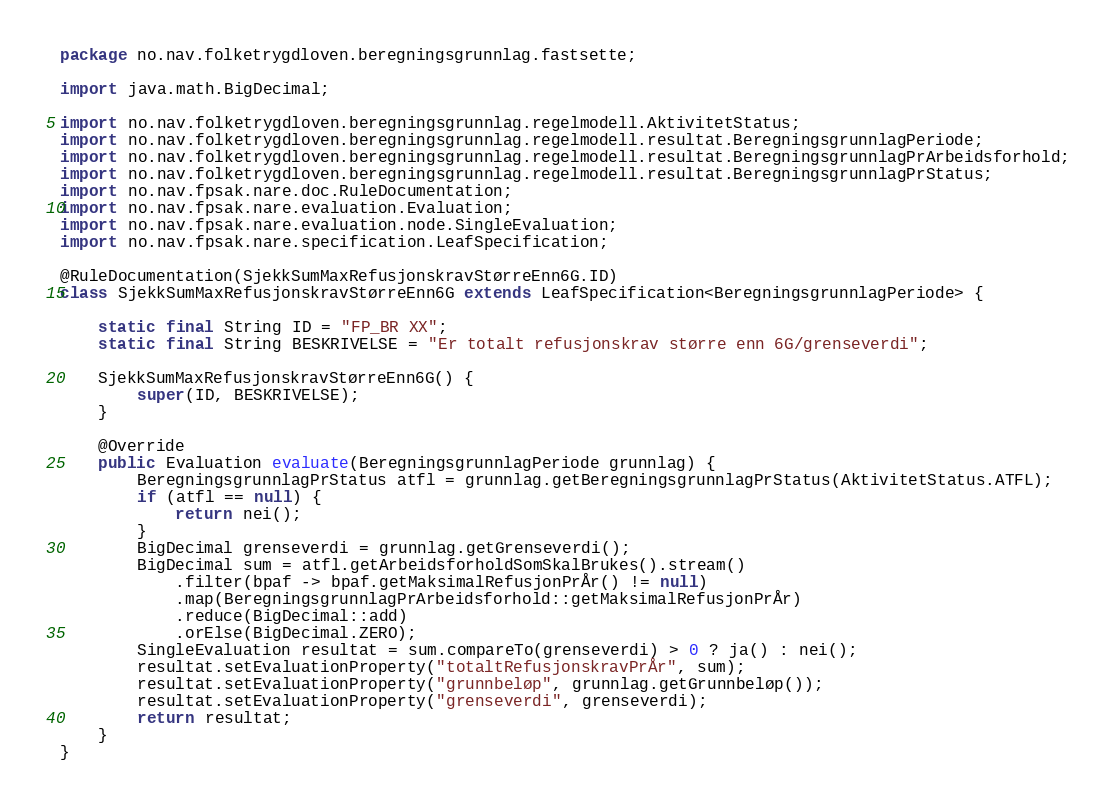Convert code to text. <code><loc_0><loc_0><loc_500><loc_500><_Java_>package no.nav.folketrygdloven.beregningsgrunnlag.fastsette;

import java.math.BigDecimal;

import no.nav.folketrygdloven.beregningsgrunnlag.regelmodell.AktivitetStatus;
import no.nav.folketrygdloven.beregningsgrunnlag.regelmodell.resultat.BeregningsgrunnlagPeriode;
import no.nav.folketrygdloven.beregningsgrunnlag.regelmodell.resultat.BeregningsgrunnlagPrArbeidsforhold;
import no.nav.folketrygdloven.beregningsgrunnlag.regelmodell.resultat.BeregningsgrunnlagPrStatus;
import no.nav.fpsak.nare.doc.RuleDocumentation;
import no.nav.fpsak.nare.evaluation.Evaluation;
import no.nav.fpsak.nare.evaluation.node.SingleEvaluation;
import no.nav.fpsak.nare.specification.LeafSpecification;

@RuleDocumentation(SjekkSumMaxRefusjonskravStørreEnn6G.ID)
class SjekkSumMaxRefusjonskravStørreEnn6G extends LeafSpecification<BeregningsgrunnlagPeriode> {

    static final String ID = "FP_BR XX";
    static final String BESKRIVELSE = "Er totalt refusjonskrav større enn 6G/grenseverdi";

    SjekkSumMaxRefusjonskravStørreEnn6G() {
        super(ID, BESKRIVELSE);
    }

    @Override
    public Evaluation evaluate(BeregningsgrunnlagPeriode grunnlag) {
        BeregningsgrunnlagPrStatus atfl = grunnlag.getBeregningsgrunnlagPrStatus(AktivitetStatus.ATFL);
        if (atfl == null) {
            return nei();
        }
        BigDecimal grenseverdi = grunnlag.getGrenseverdi();
        BigDecimal sum = atfl.getArbeidsforholdSomSkalBrukes().stream()
            .filter(bpaf -> bpaf.getMaksimalRefusjonPrÅr() != null)
            .map(BeregningsgrunnlagPrArbeidsforhold::getMaksimalRefusjonPrÅr)
            .reduce(BigDecimal::add)
            .orElse(BigDecimal.ZERO);
        SingleEvaluation resultat = sum.compareTo(grenseverdi) > 0 ? ja() : nei();
        resultat.setEvaluationProperty("totaltRefusjonskravPrÅr", sum);
        resultat.setEvaluationProperty("grunnbeløp", grunnlag.getGrunnbeløp());
        resultat.setEvaluationProperty("grenseverdi", grenseverdi);
        return resultat;
    }
}
</code> 